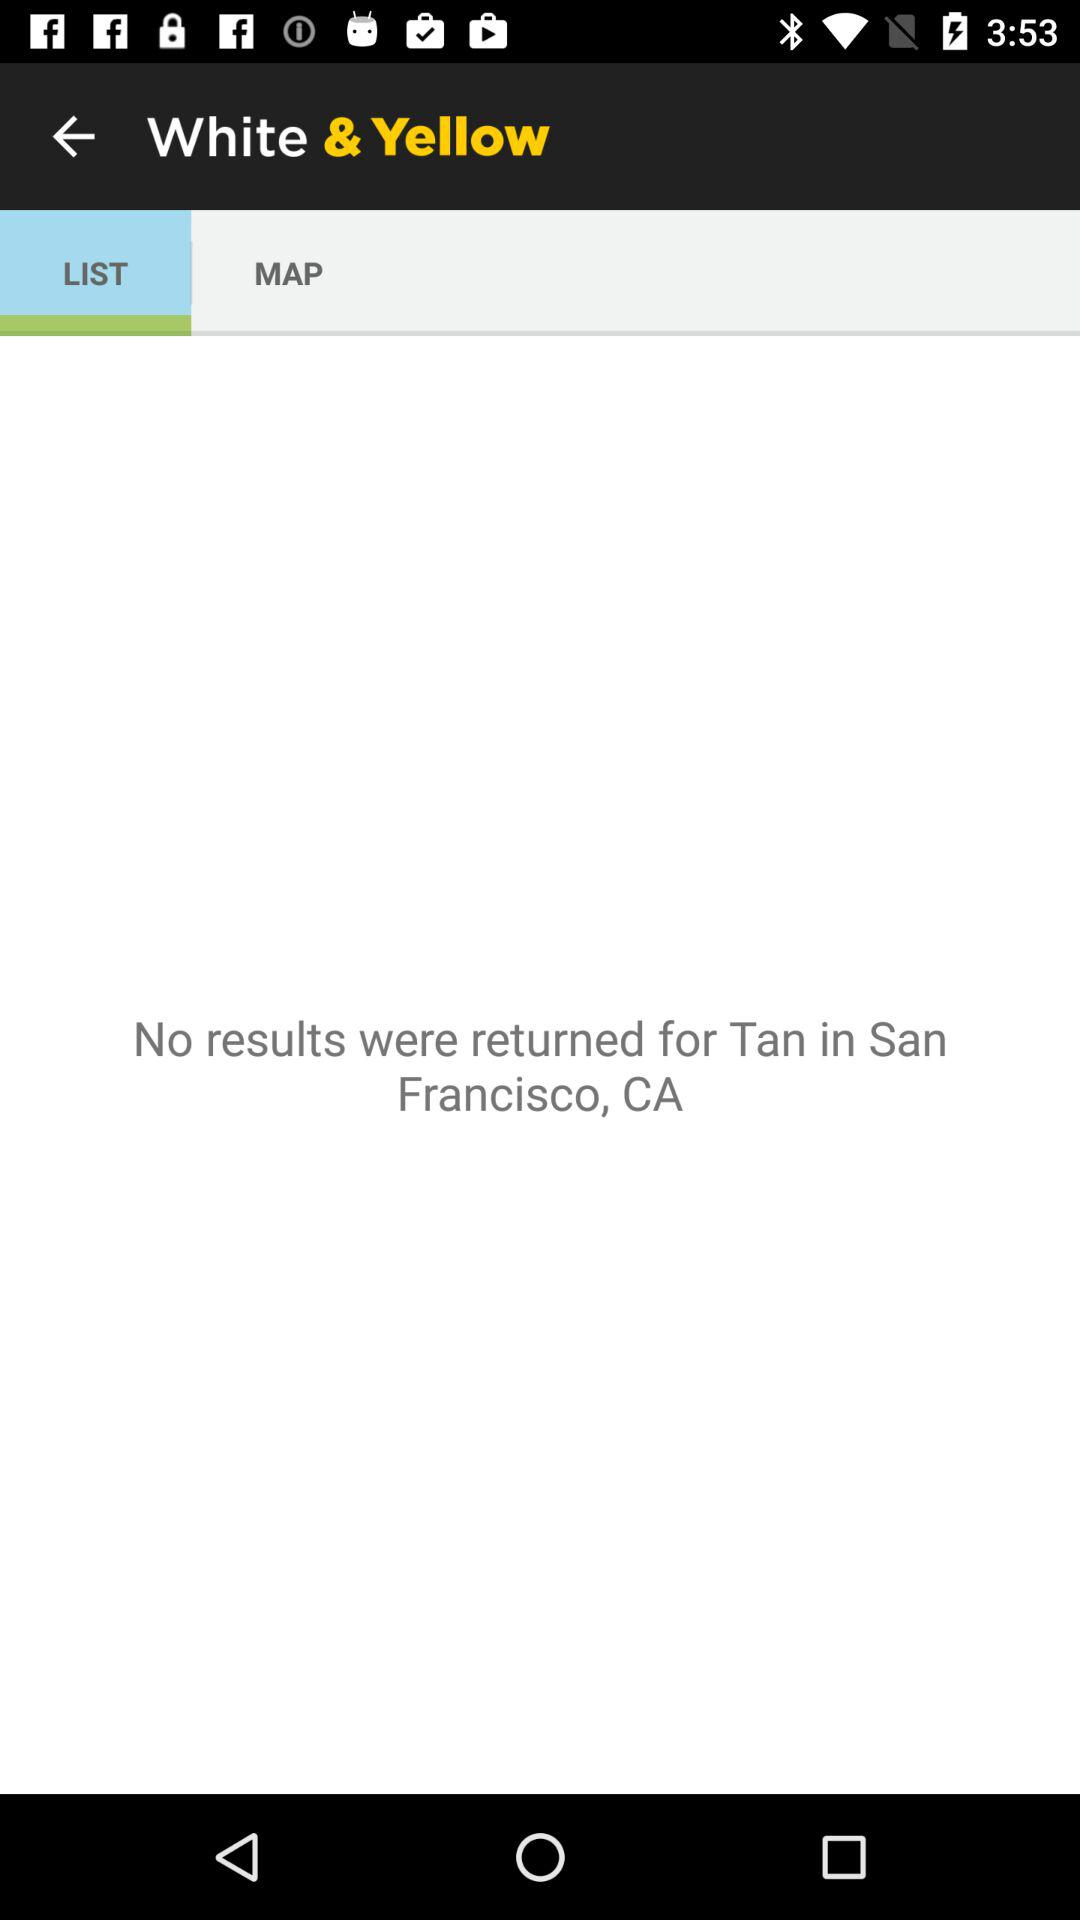What is the mentioned location? The mentioned location is San Francisco, CA. 